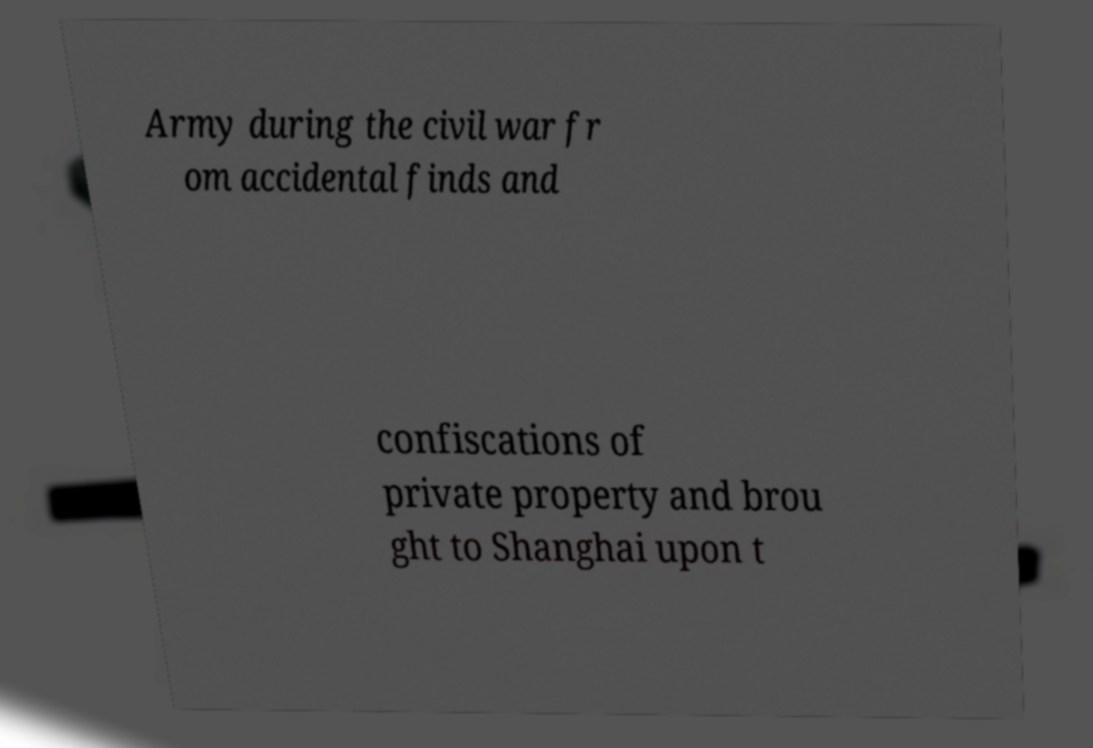Please read and relay the text visible in this image. What does it say? Army during the civil war fr om accidental finds and confiscations of private property and brou ght to Shanghai upon t 